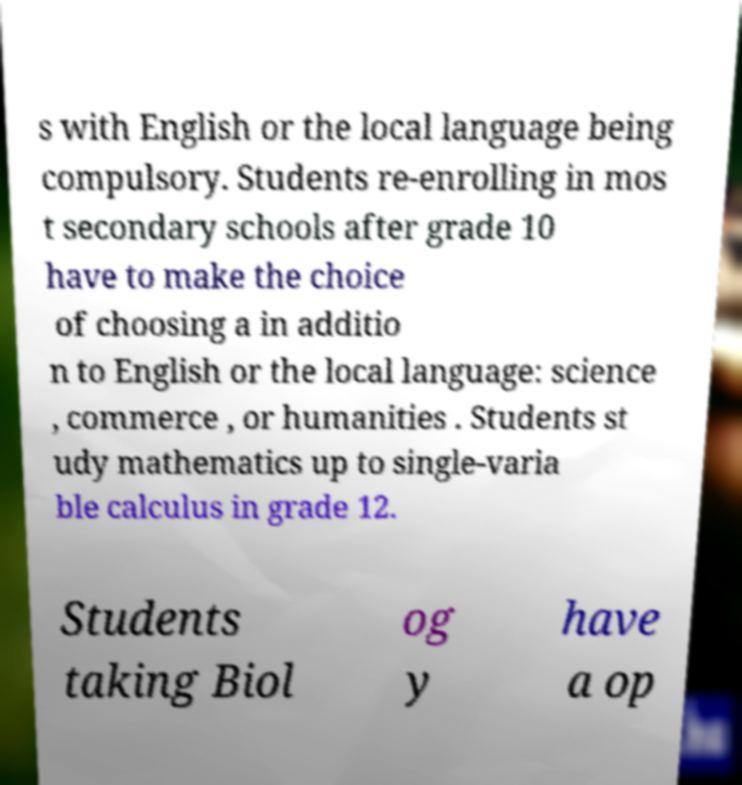What messages or text are displayed in this image? I need them in a readable, typed format. s with English or the local language being compulsory. Students re-enrolling in mos t secondary schools after grade 10 have to make the choice of choosing a in additio n to English or the local language: science , commerce , or humanities . Students st udy mathematics up to single-varia ble calculus in grade 12. Students taking Biol og y have a op 